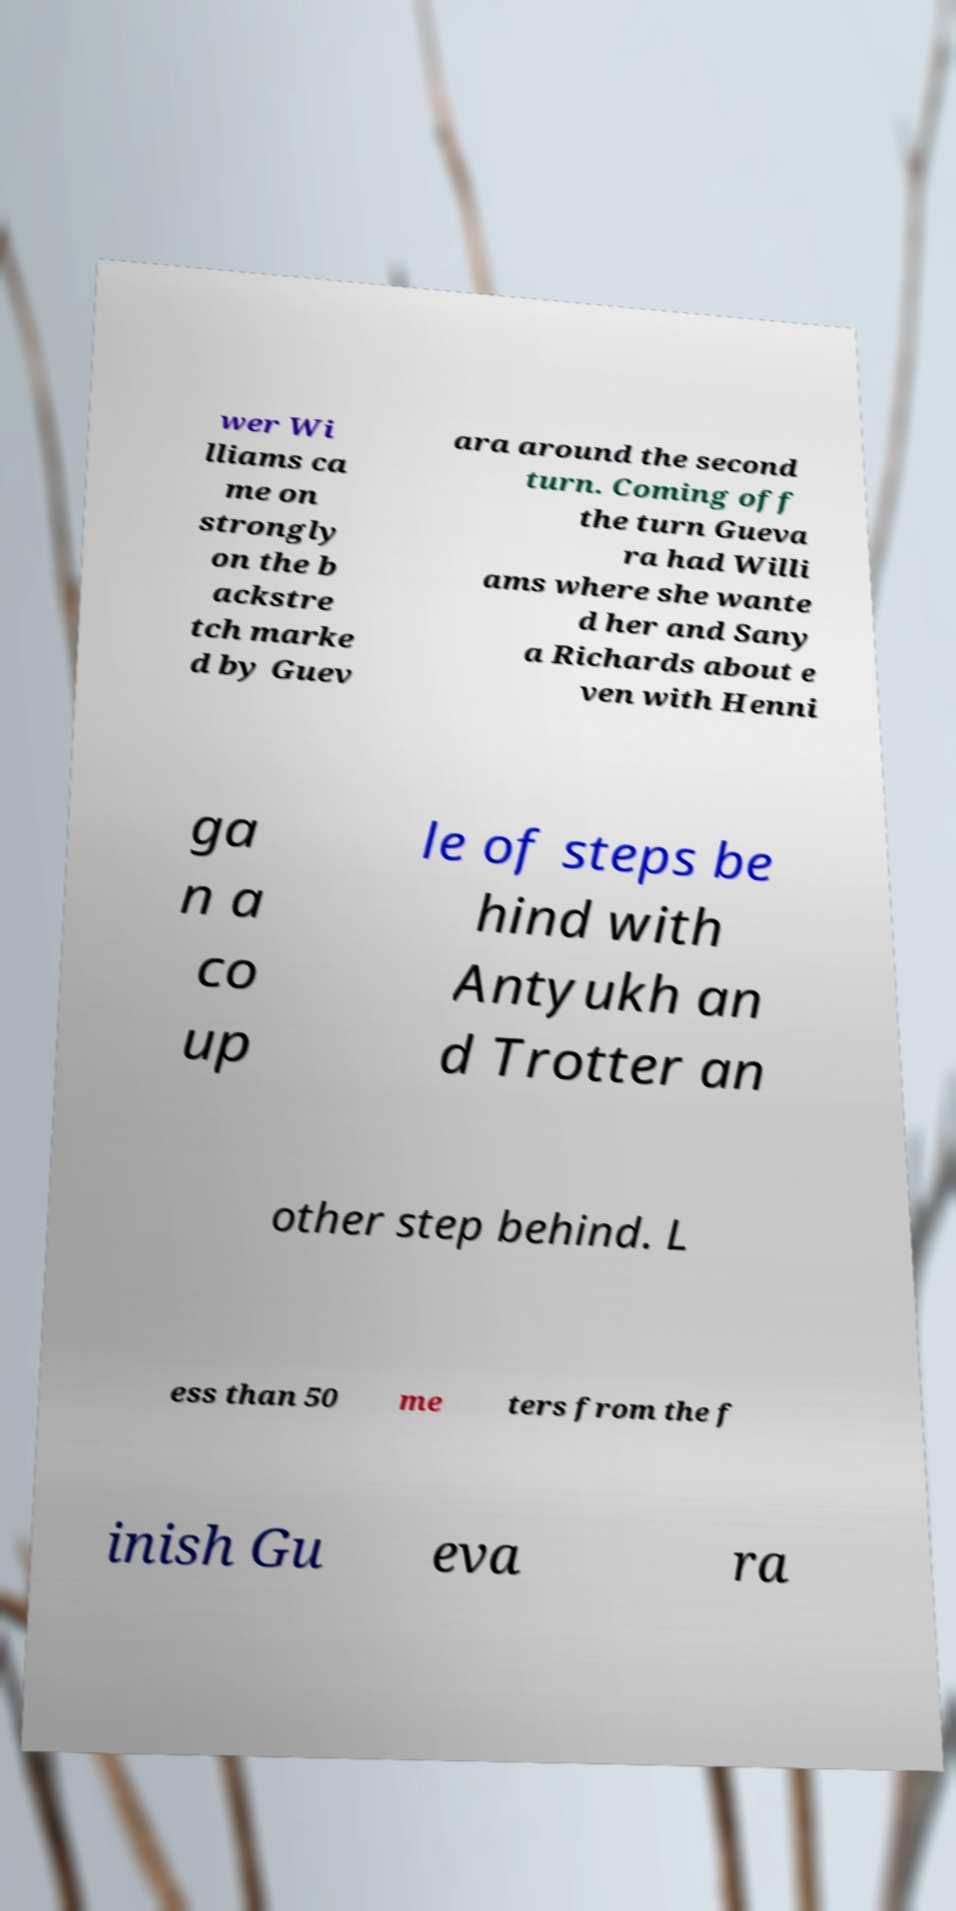Please identify and transcribe the text found in this image. wer Wi lliams ca me on strongly on the b ackstre tch marke d by Guev ara around the second turn. Coming off the turn Gueva ra had Willi ams where she wante d her and Sany a Richards about e ven with Henni ga n a co up le of steps be hind with Antyukh an d Trotter an other step behind. L ess than 50 me ters from the f inish Gu eva ra 